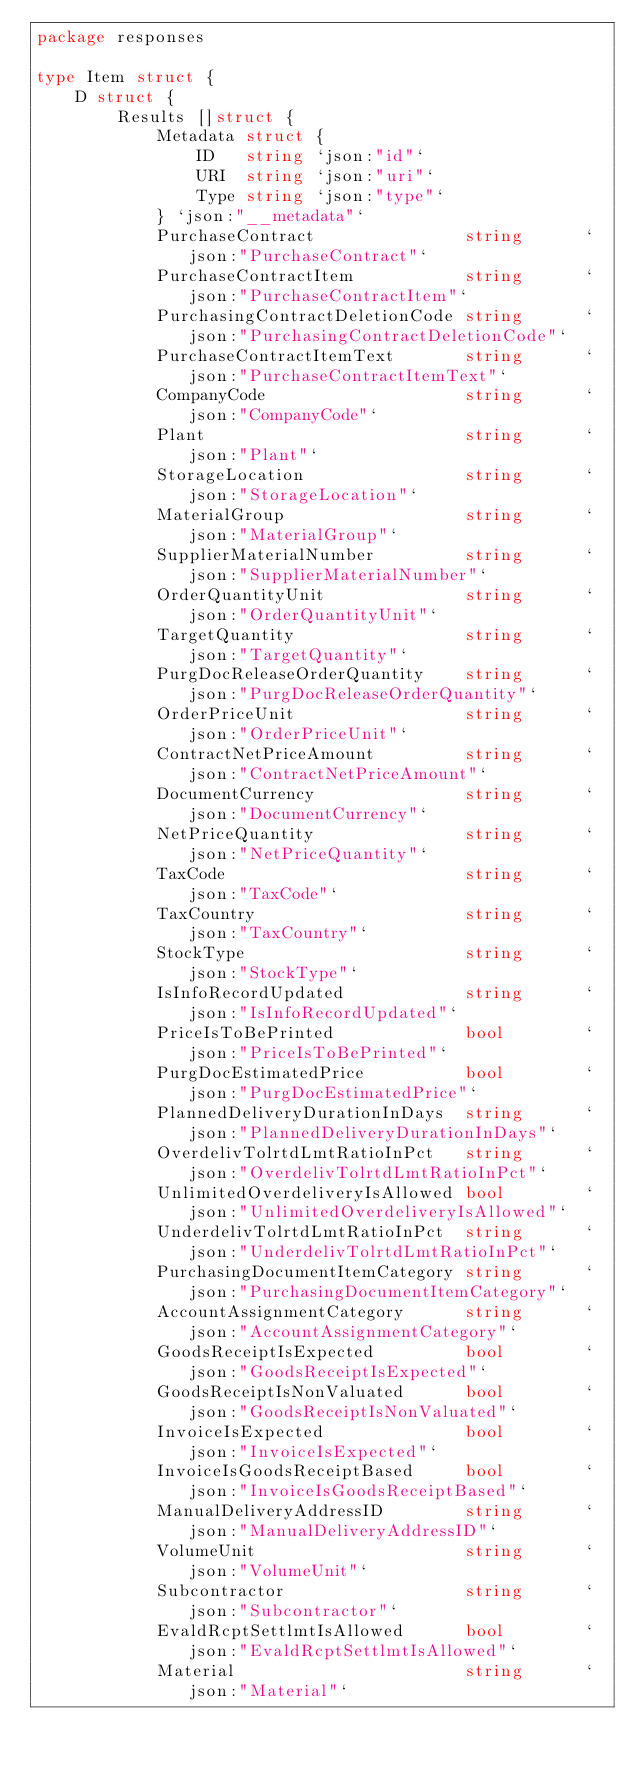<code> <loc_0><loc_0><loc_500><loc_500><_Go_>package responses

type Item struct {
	D struct {
		Results []struct {
			Metadata struct {
				ID   string `json:"id"`
				URI  string `json:"uri"`
				Type string `json:"type"`
			} `json:"__metadata"`
			PurchaseContract               string      `json:"PurchaseContract"`
			PurchaseContractItem           string      `json:"PurchaseContractItem"`
			PurchasingContractDeletionCode string      `json:"PurchasingContractDeletionCode"`
			PurchaseContractItemText       string      `json:"PurchaseContractItemText"`
			CompanyCode                    string      `json:"CompanyCode"`
			Plant                          string      `json:"Plant"`
			StorageLocation                string      `json:"StorageLocation"`
			MaterialGroup                  string      `json:"MaterialGroup"`
			SupplierMaterialNumber         string      `json:"SupplierMaterialNumber"`
			OrderQuantityUnit              string      `json:"OrderQuantityUnit"`
			TargetQuantity                 string      `json:"TargetQuantity"`
			PurgDocReleaseOrderQuantity    string      `json:"PurgDocReleaseOrderQuantity"`
			OrderPriceUnit                 string      `json:"OrderPriceUnit"`
			ContractNetPriceAmount         string      `json:"ContractNetPriceAmount"`
			DocumentCurrency               string      `json:"DocumentCurrency"`
			NetPriceQuantity               string      `json:"NetPriceQuantity"`
			TaxCode                        string      `json:"TaxCode"`
			TaxCountry                     string      `json:"TaxCountry"`
			StockType                      string      `json:"StockType"`
			IsInfoRecordUpdated            string      `json:"IsInfoRecordUpdated"`
			PriceIsToBePrinted             bool        `json:"PriceIsToBePrinted"`
			PurgDocEstimatedPrice          bool        `json:"PurgDocEstimatedPrice"`
			PlannedDeliveryDurationInDays  string      `json:"PlannedDeliveryDurationInDays"`
			OverdelivTolrtdLmtRatioInPct   string      `json:"OverdelivTolrtdLmtRatioInPct"`
			UnlimitedOverdeliveryIsAllowed bool        `json:"UnlimitedOverdeliveryIsAllowed"`
			UnderdelivTolrtdLmtRatioInPct  string      `json:"UnderdelivTolrtdLmtRatioInPct"`
			PurchasingDocumentItemCategory string      `json:"PurchasingDocumentItemCategory"`
			AccountAssignmentCategory      string      `json:"AccountAssignmentCategory"`
			GoodsReceiptIsExpected         bool        `json:"GoodsReceiptIsExpected"`
			GoodsReceiptIsNonValuated      bool        `json:"GoodsReceiptIsNonValuated"`
			InvoiceIsExpected              bool        `json:"InvoiceIsExpected"`
			InvoiceIsGoodsReceiptBased     bool        `json:"InvoiceIsGoodsReceiptBased"`
			ManualDeliveryAddressID        string      `json:"ManualDeliveryAddressID"`
			VolumeUnit                     string      `json:"VolumeUnit"`
			Subcontractor                  string      `json:"Subcontractor"`
			EvaldRcptSettlmtIsAllowed      bool        `json:"EvaldRcptSettlmtIsAllowed"`
			Material                       string      `json:"Material"`</code> 